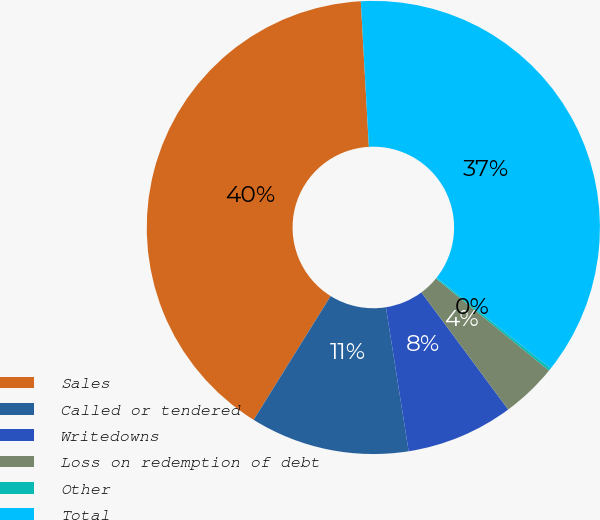Convert chart to OTSL. <chart><loc_0><loc_0><loc_500><loc_500><pie_chart><fcel>Sales<fcel>Called or tendered<fcel>Writedowns<fcel>Loss on redemption of debt<fcel>Other<fcel>Total<nl><fcel>40.26%<fcel>11.35%<fcel>7.66%<fcel>3.97%<fcel>0.19%<fcel>36.57%<nl></chart> 